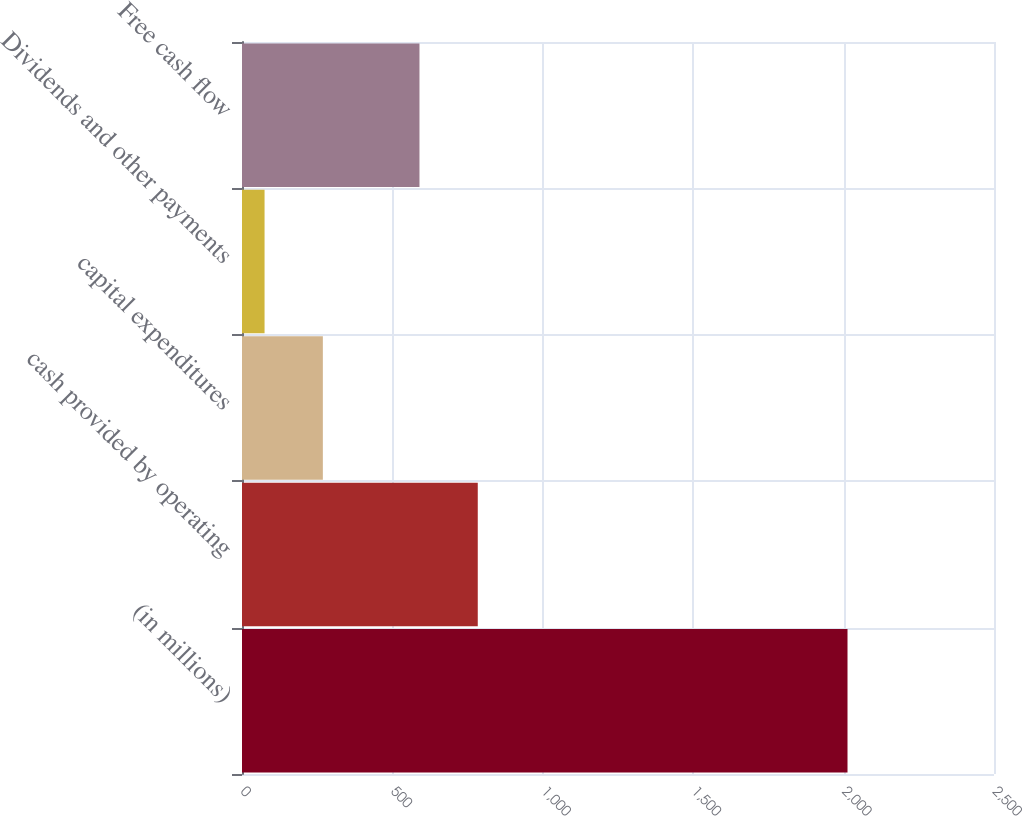<chart> <loc_0><loc_0><loc_500><loc_500><bar_chart><fcel>(in millions)<fcel>cash provided by operating<fcel>capital expenditures<fcel>Dividends and other payments<fcel>Free cash flow<nl><fcel>2013<fcel>783.8<fcel>268.8<fcel>75<fcel>590<nl></chart> 